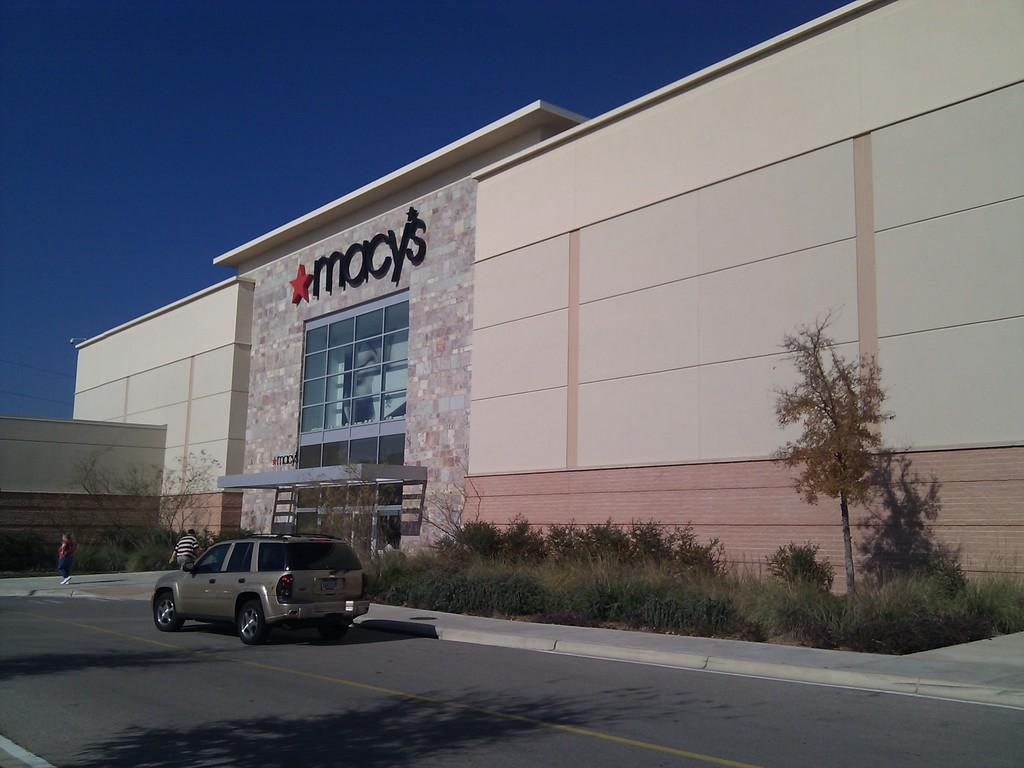What is the main structure in the image? There is a building with text in the image. What other features can be seen in the image? There is a wall, a road, a vehicle, two people, trees, plants, and the sky visible in the image. What type of fruit can be seen growing in the plantation in the image? There is no plantation or fruit present in the image. What does the image smell like? The image is a visual representation and does not have a smell. 